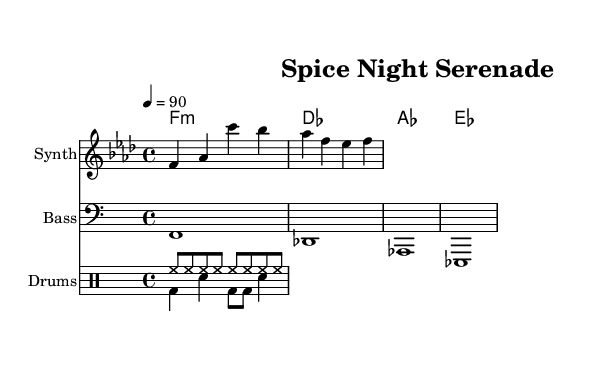What is the key signature of this music? The key signature is F minor, which has four flats: B♭, E♭, A♭, and D♭.
Answer: F minor What is the time signature of this music? The time signature is indicated by the 4/4 notation, meaning there are four beats in each measure and the quarter note gets one beat.
Answer: 4/4 What is the tempo marking of this piece? The tempo marking is indicated as quarter note equals 90 beats per minute, which provides a moderate pace for the piece.
Answer: 90 How many measures are in the melody section? The melody section consists of two measures as indicated by the vertical bar lines, which separate different measures in the sheet music.
Answer: 2 What type of music is “Spice Night Serenade”? This piece is categorized as Chill electronic lounge music, which is often characterized by its relaxed beats and smooth melodies, ideal for late-night cooking sessions.
Answer: Chill electronic lounge How many instruments are written in the score? The score includes three distinct instruments: Synth for the melody, Bass for the bass line, and Drums for the percussion patterns.
Answer: 3 What is the first chord in the harmonies? The first chord in the harmonies is F minor, as indicated at the start of the chord progression in the sheet music.
Answer: F minor 